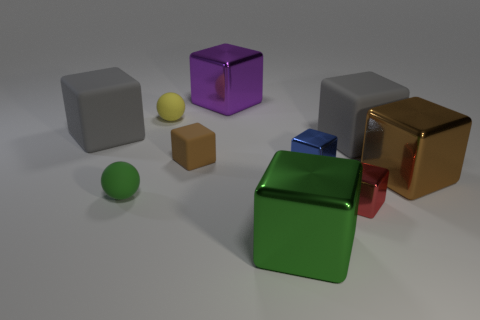How many objects are tiny rubber spheres in front of the tiny brown block or large matte things that are left of the yellow thing?
Provide a succinct answer. 2. Are there any other things that have the same shape as the big purple metal thing?
Ensure brevity in your answer.  Yes. What number of purple shiny blocks are there?
Keep it short and to the point. 1. Are there any other purple shiny blocks of the same size as the purple metallic cube?
Make the answer very short. No. Are the big green object and the brown object left of the small red block made of the same material?
Your response must be concise. No. What is the material of the big gray thing that is on the left side of the large green metal cube?
Your answer should be very brief. Rubber. What size is the blue metallic object?
Ensure brevity in your answer.  Small. Do the matte ball behind the brown metallic block and the gray matte cube that is left of the tiny yellow rubber sphere have the same size?
Your answer should be very brief. No. What size is the other matte thing that is the same shape as the small yellow thing?
Give a very brief answer. Small. Does the blue metal block have the same size as the gray rubber object that is on the left side of the small green sphere?
Offer a terse response. No. 